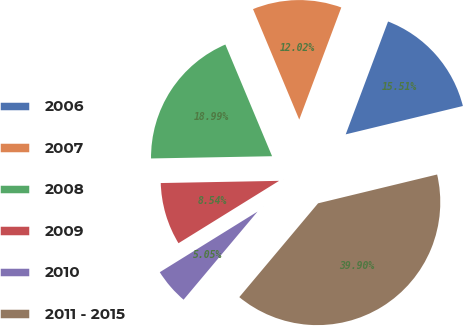Convert chart to OTSL. <chart><loc_0><loc_0><loc_500><loc_500><pie_chart><fcel>2006<fcel>2007<fcel>2008<fcel>2009<fcel>2010<fcel>2011 - 2015<nl><fcel>15.51%<fcel>12.02%<fcel>18.99%<fcel>8.54%<fcel>5.05%<fcel>39.9%<nl></chart> 